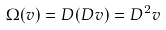<formula> <loc_0><loc_0><loc_500><loc_500>\Omega ( v ) = D ( D v ) = D ^ { 2 } v</formula> 